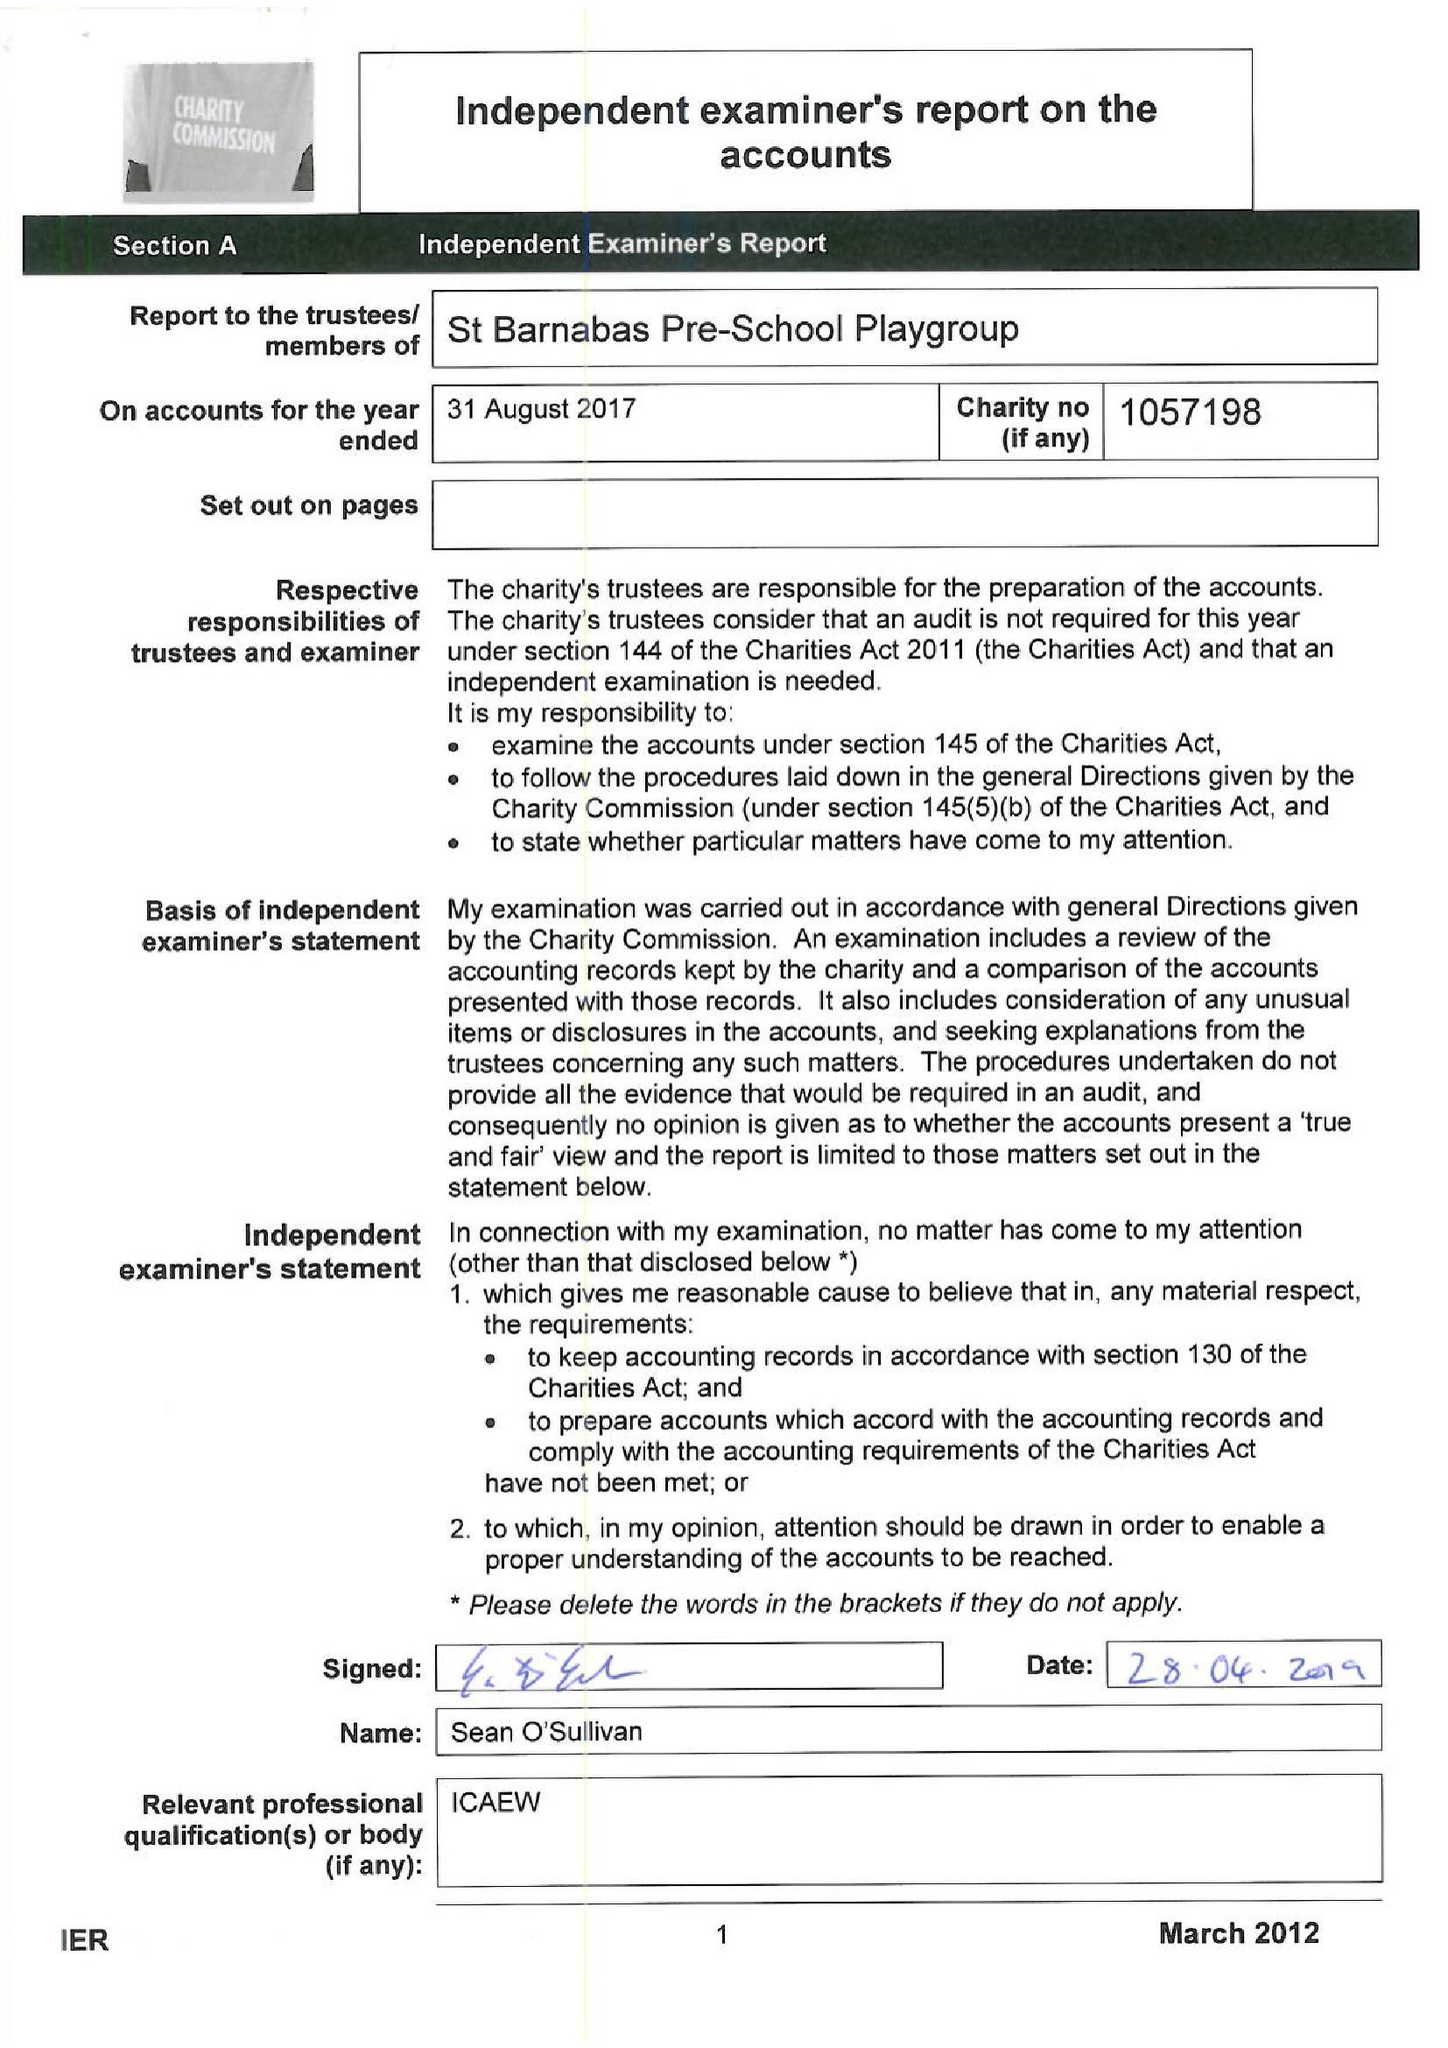What is the value for the charity_number?
Answer the question using a single word or phrase. 1057198 